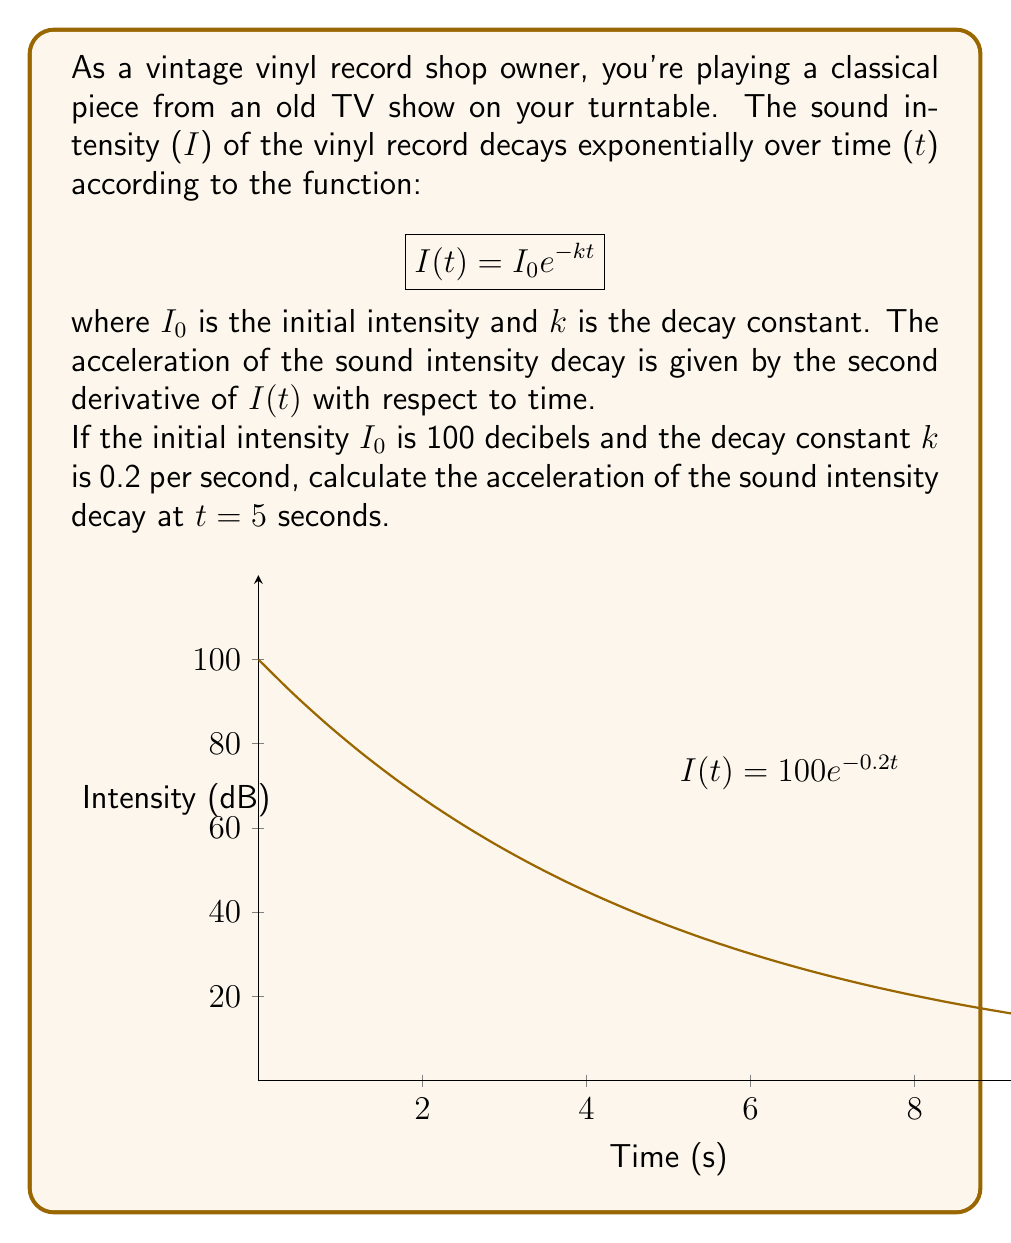Teach me how to tackle this problem. Let's approach this step-by-step:

1) We start with the given function: $I(t) = I_0 e^{-kt}$

2) We're told that $I_0 = 100$ and $k = 0.2$, so our specific function is:
   $$I(t) = 100 e^{-0.2t}$$

3) To find the acceleration, we need the second derivative of $I(t)$ with respect to $t$. Let's calculate this:

4) First derivative:
   $$\frac{dI}{dt} = -0.2 \cdot 100 e^{-0.2t} = -20 e^{-0.2t}$$

5) Second derivative:
   $$\frac{d^2I}{dt^2} = -20 \cdot (-0.2) e^{-0.2t} = 4 e^{-0.2t}$$

6) This second derivative represents the acceleration of the sound intensity decay.

7) We need to evaluate this at $t = 5$ seconds:
   $$\frac{d^2I}{dt^2}\bigg|_{t=5} = 4 e^{-0.2 \cdot 5} = 4 e^{-1} \approx 1.47$$

8) The units for this acceleration would be decibels per second squared (dB/s²).
Answer: $1.47$ dB/s² 